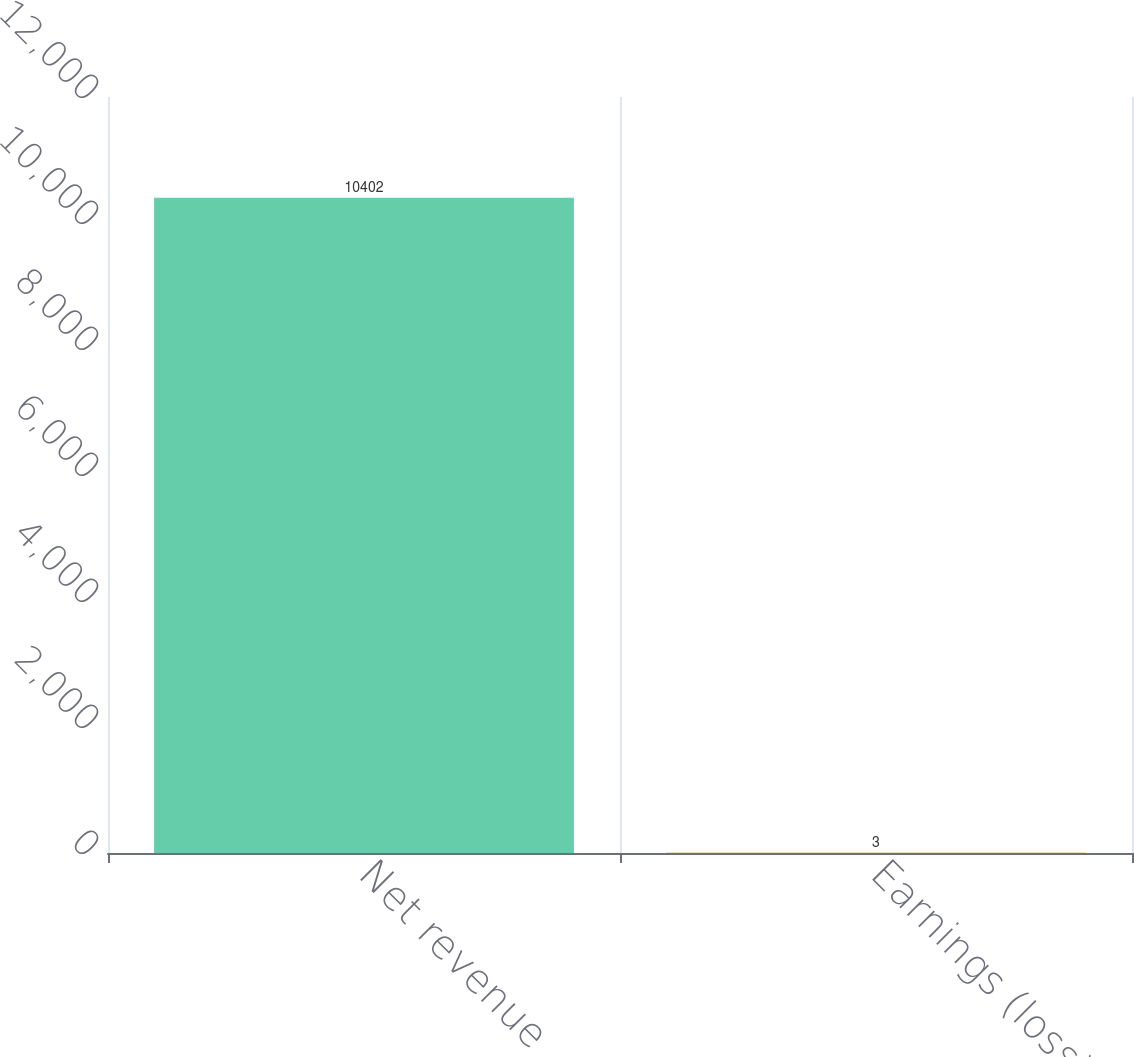<chart> <loc_0><loc_0><loc_500><loc_500><bar_chart><fcel>Net revenue<fcel>Earnings (loss) from<nl><fcel>10402<fcel>3<nl></chart> 